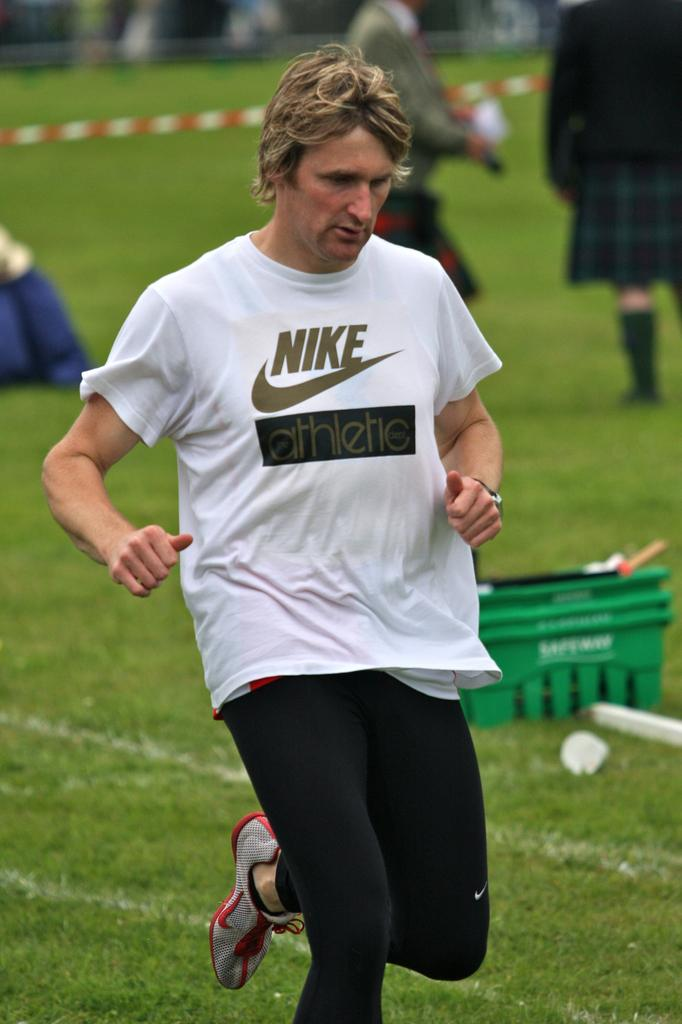Who is the main subject in the image? There is a man in the center of the image. What is the setting of the image? The man is on a grassland. Can you describe the background of the image? There are people, a barrier tape, and a car in the background of the image. What type of flowers can be seen in the library in the image? There is no library or flowers present in the image. 